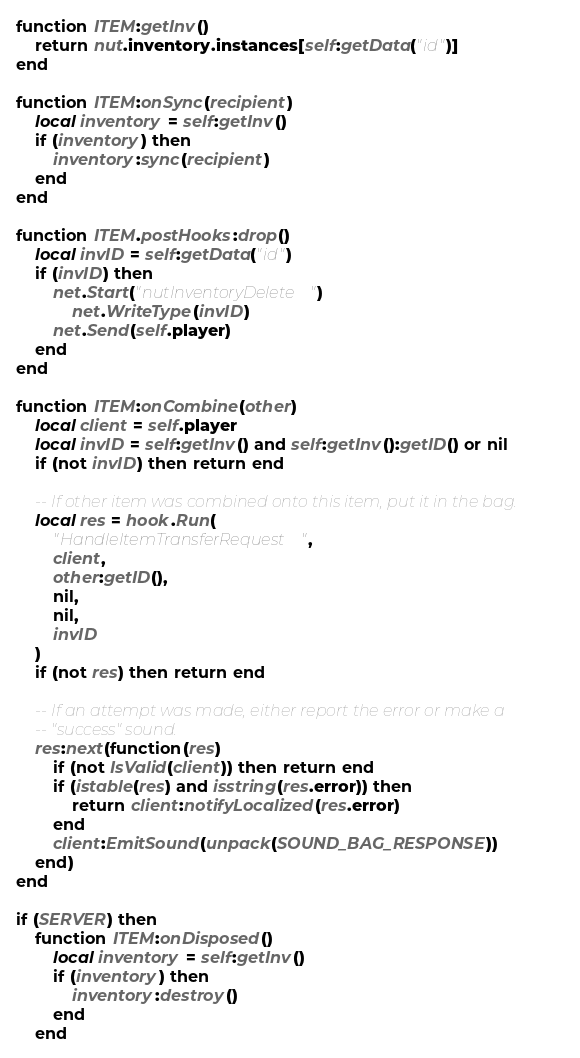<code> <loc_0><loc_0><loc_500><loc_500><_Lua_>
function ITEM:getInv()
	return nut.inventory.instances[self:getData("id")]
end

function ITEM:onSync(recipient)
	local inventory = self:getInv()
	if (inventory) then
		inventory:sync(recipient)
	end
end

function ITEM.postHooks:drop()
	local invID = self:getData("id")
	if (invID) then
		net.Start("nutInventoryDelete")
			net.WriteType(invID)
		net.Send(self.player)
	end
end

function ITEM:onCombine(other)
	local client = self.player
	local invID = self:getInv() and self:getInv():getID() or nil
	if (not invID) then return end

	-- If other item was combined onto this item, put it in the bag.
	local res = hook.Run(
		"HandleItemTransferRequest",
		client,
		other:getID(),
		nil,
		nil,
		invID
	)
	if (not res) then return end

	-- If an attempt was made, either report the error or make a
	-- "success" sound.
	res:next(function(res)
		if (not IsValid(client)) then return end
		if (istable(res) and isstring(res.error)) then
			return client:notifyLocalized(res.error)
		end
		client:EmitSound(unpack(SOUND_BAG_RESPONSE))
	end)
end

if (SERVER) then
	function ITEM:onDisposed()
		local inventory = self:getInv()
		if (inventory) then
			inventory:destroy()
		end
	end
</code> 